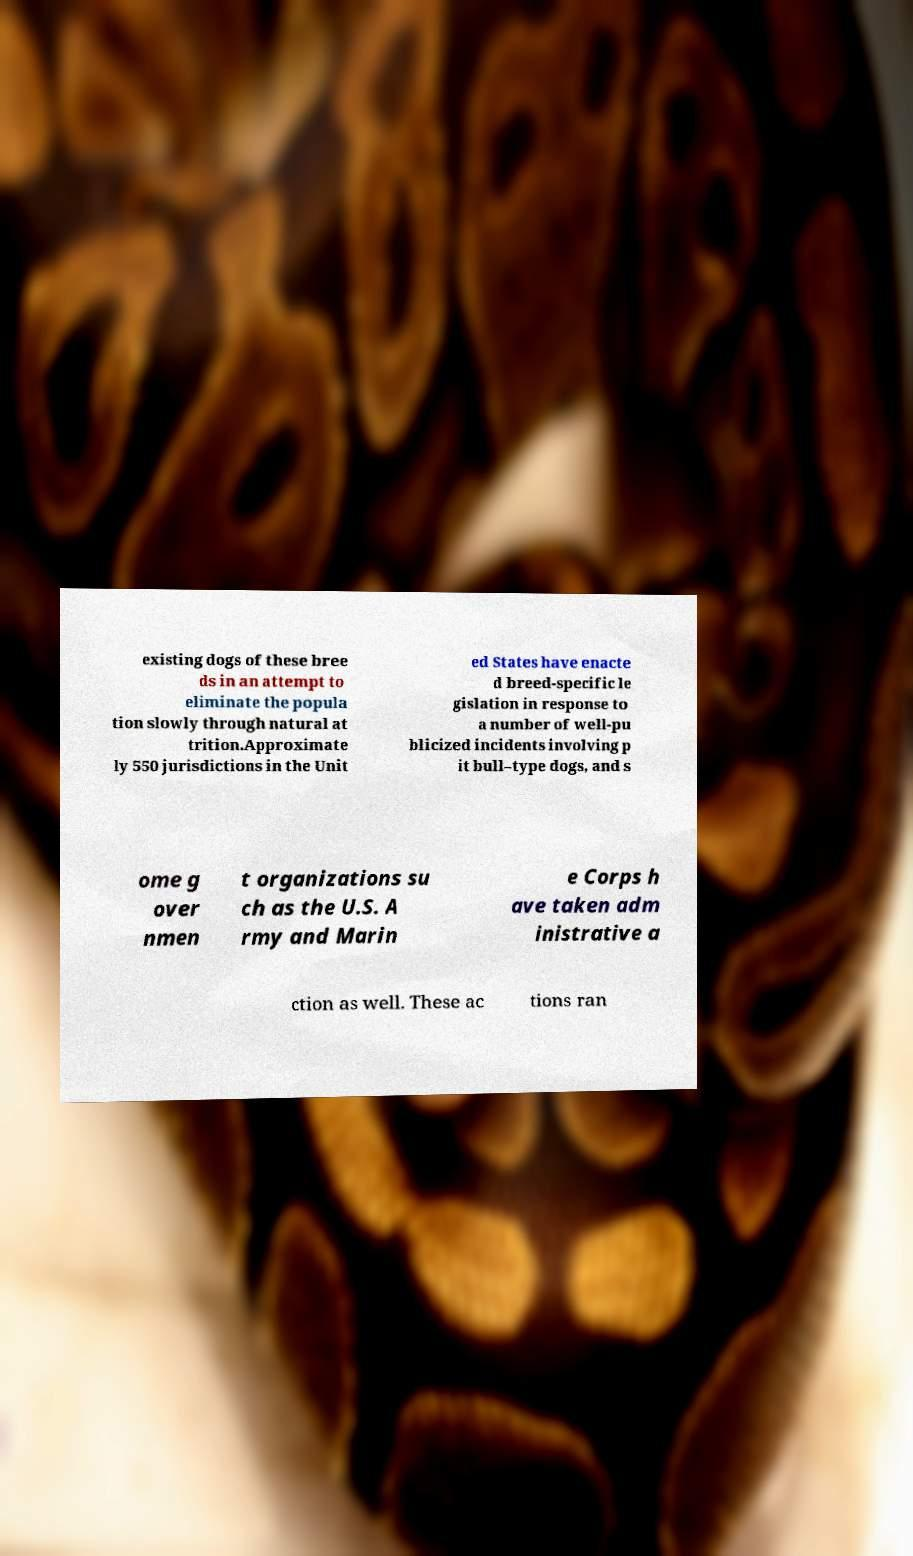I need the written content from this picture converted into text. Can you do that? existing dogs of these bree ds in an attempt to eliminate the popula tion slowly through natural at trition.Approximate ly 550 jurisdictions in the Unit ed States have enacte d breed-specific le gislation in response to a number of well-pu blicized incidents involving p it bull–type dogs, and s ome g over nmen t organizations su ch as the U.S. A rmy and Marin e Corps h ave taken adm inistrative a ction as well. These ac tions ran 